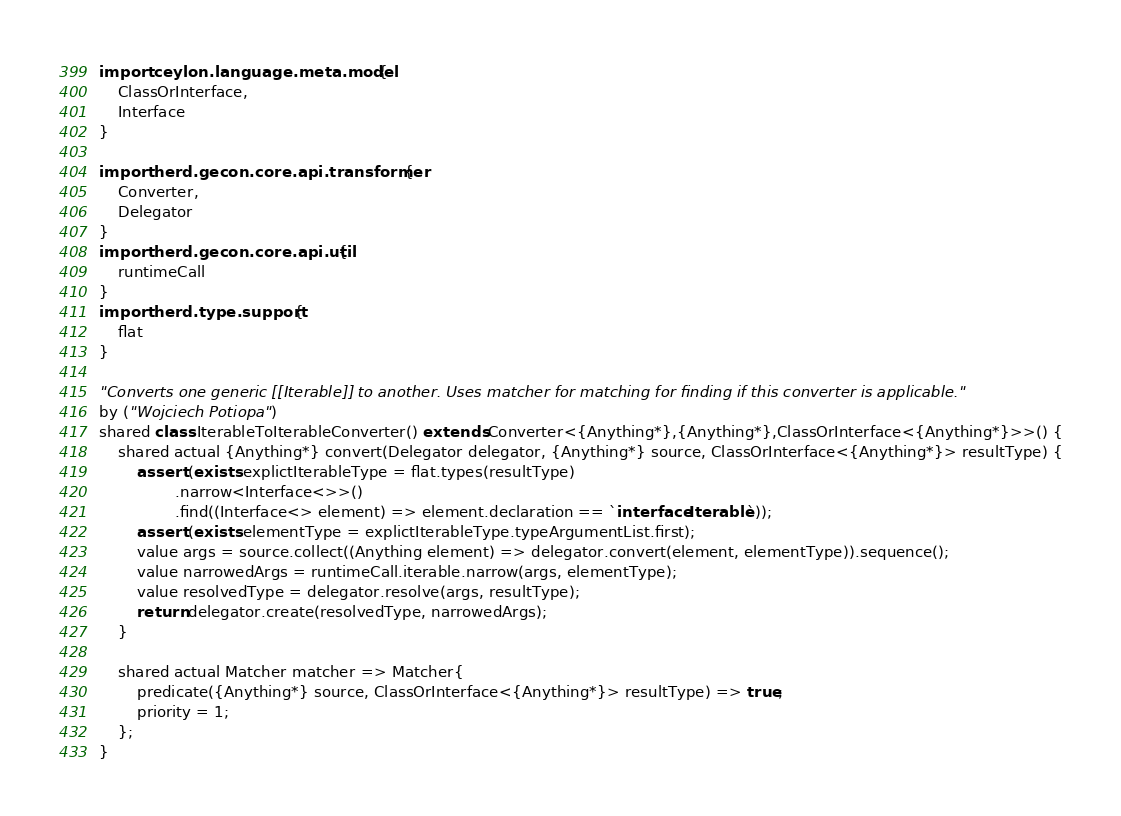Convert code to text. <code><loc_0><loc_0><loc_500><loc_500><_Ceylon_>import ceylon.language.meta.model {
	ClassOrInterface,
	Interface
}

import herd.gecon.core.api.transformer {
	Converter,
	Delegator
}
import herd.gecon.core.api.util {
	runtimeCall
}
import herd.type.support {
	flat
}

"Converts one generic [[Iterable]] to another. Uses matcher for matching for finding if this converter is applicable."
by ("Wojciech Potiopa")
shared class IterableToIterableConverter() extends Converter<{Anything*},{Anything*},ClassOrInterface<{Anything*}>>() {
	shared actual {Anything*} convert(Delegator delegator, {Anything*} source, ClassOrInterface<{Anything*}> resultType) {
		assert (exists explictIterableType = flat.types(resultType)
				.narrow<Interface<>>()
				.find((Interface<> element) => element.declaration == `interface Iterable`));
		assert (exists elementType = explictIterableType.typeArgumentList.first);
		value args = source.collect((Anything element) => delegator.convert(element, elementType)).sequence();
		value narrowedArgs = runtimeCall.iterable.narrow(args, elementType);
		value resolvedType = delegator.resolve(args, resultType);
		return delegator.create(resolvedType, narrowedArgs);
	}
	
	shared actual Matcher matcher => Matcher{
		predicate({Anything*} source, ClassOrInterface<{Anything*}> resultType) => true;
		priority = 1;
	};
}
</code> 